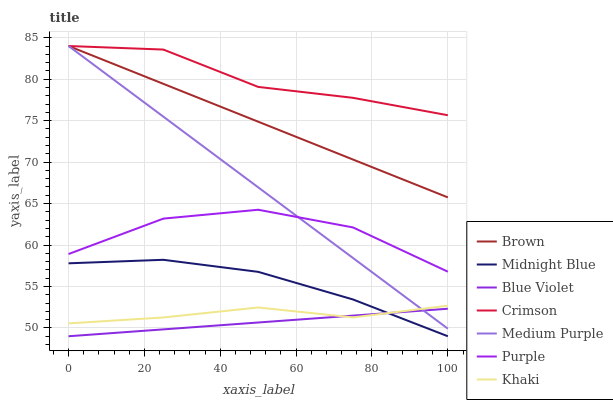Does Blue Violet have the minimum area under the curve?
Answer yes or no. Yes. Does Crimson have the maximum area under the curve?
Answer yes or no. Yes. Does Khaki have the minimum area under the curve?
Answer yes or no. No. Does Khaki have the maximum area under the curve?
Answer yes or no. No. Is Brown the smoothest?
Answer yes or no. Yes. Is Purple the roughest?
Answer yes or no. Yes. Is Khaki the smoothest?
Answer yes or no. No. Is Khaki the roughest?
Answer yes or no. No. Does Midnight Blue have the lowest value?
Answer yes or no. Yes. Does Khaki have the lowest value?
Answer yes or no. No. Does Crimson have the highest value?
Answer yes or no. Yes. Does Khaki have the highest value?
Answer yes or no. No. Is Midnight Blue less than Crimson?
Answer yes or no. Yes. Is Purple greater than Blue Violet?
Answer yes or no. Yes. Does Crimson intersect Brown?
Answer yes or no. Yes. Is Crimson less than Brown?
Answer yes or no. No. Is Crimson greater than Brown?
Answer yes or no. No. Does Midnight Blue intersect Crimson?
Answer yes or no. No. 